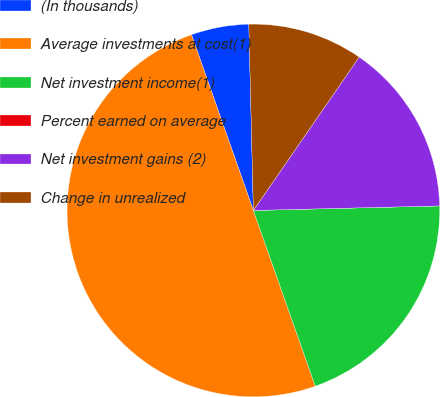<chart> <loc_0><loc_0><loc_500><loc_500><pie_chart><fcel>(In thousands)<fcel>Average investments at cost(1)<fcel>Net investment income(1)<fcel>Percent earned on average<fcel>Net investment gains (2)<fcel>Change in unrealized<nl><fcel>5.0%<fcel>50.0%<fcel>20.0%<fcel>0.0%<fcel>15.0%<fcel>10.0%<nl></chart> 